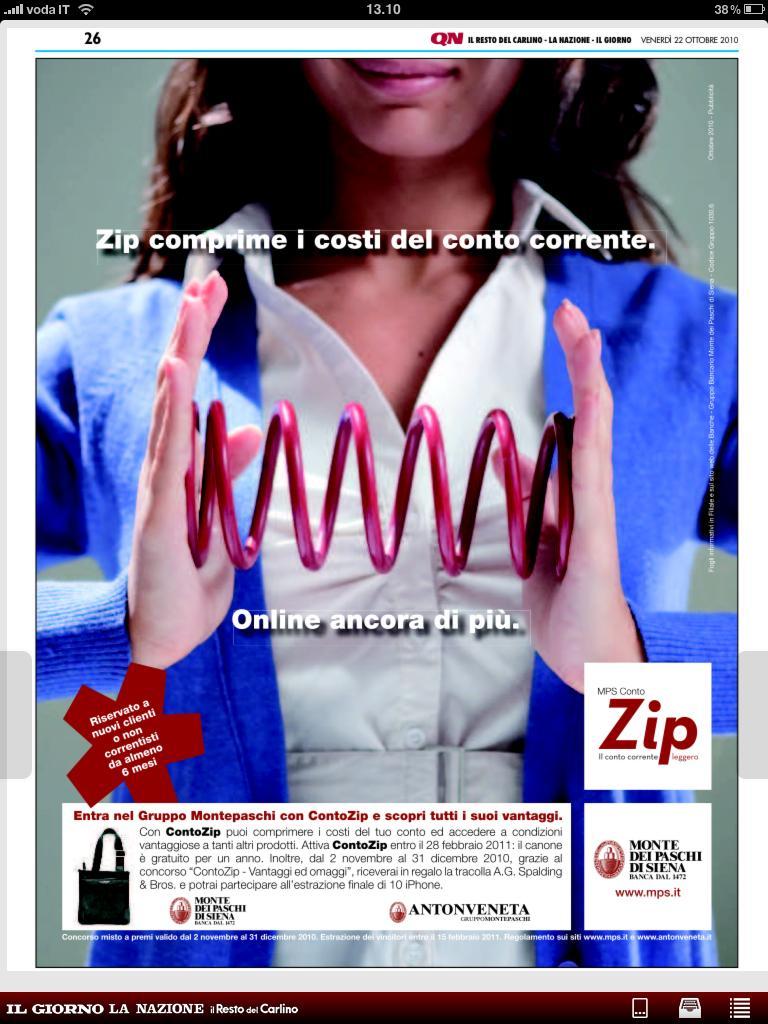How would you summarize this image in a sentence or two? In this image there is the screenshot of the screen and there is some text on it with the image of the woman holding an object which is pink in colour. 